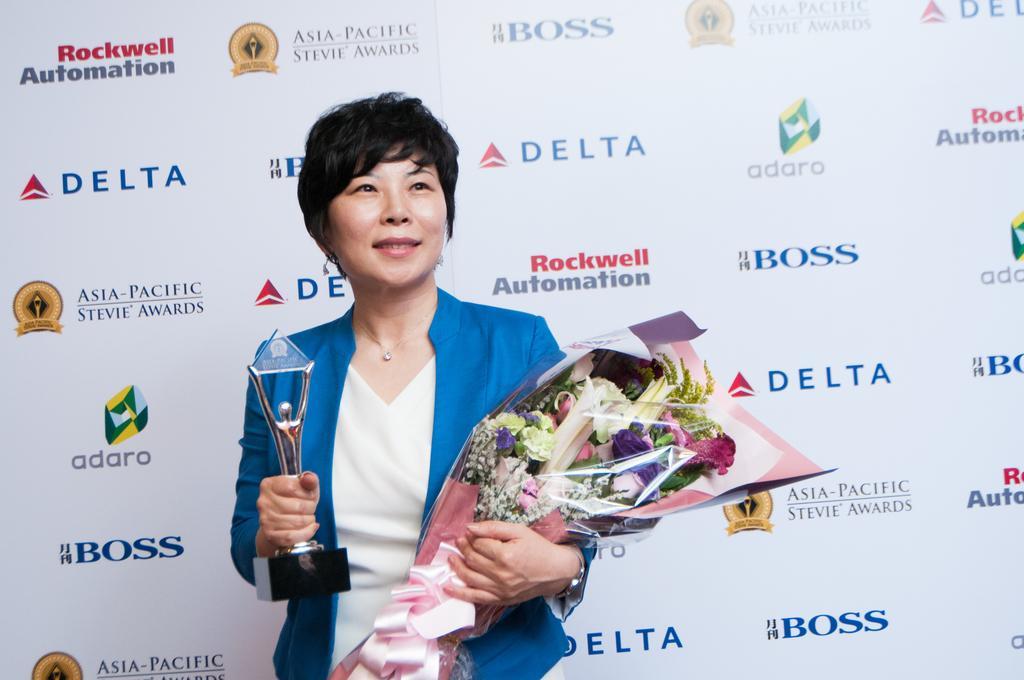Describe this image in one or two sentences. In this picture we can observe a woman holding a prize and a bouquet in her hands. She is smiling. She is wearing a blue color coat. In the background there is a white color poster on which we can observe different colors of words printed. 